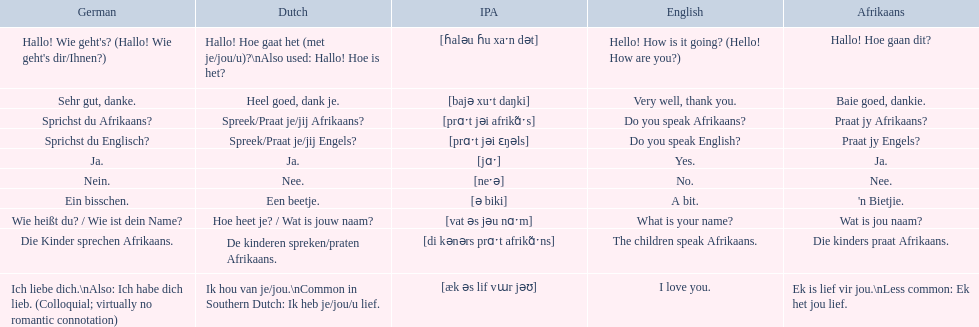Which phrases are said in africaans? Hallo! Hoe gaan dit?, Baie goed, dankie., Praat jy Afrikaans?, Praat jy Engels?, Ja., Nee., 'n Bietjie., Wat is jou naam?, Die kinders praat Afrikaans., Ek is lief vir jou.\nLess common: Ek het jou lief. Which of these mean how do you speak afrikaans? Praat jy Afrikaans?. 